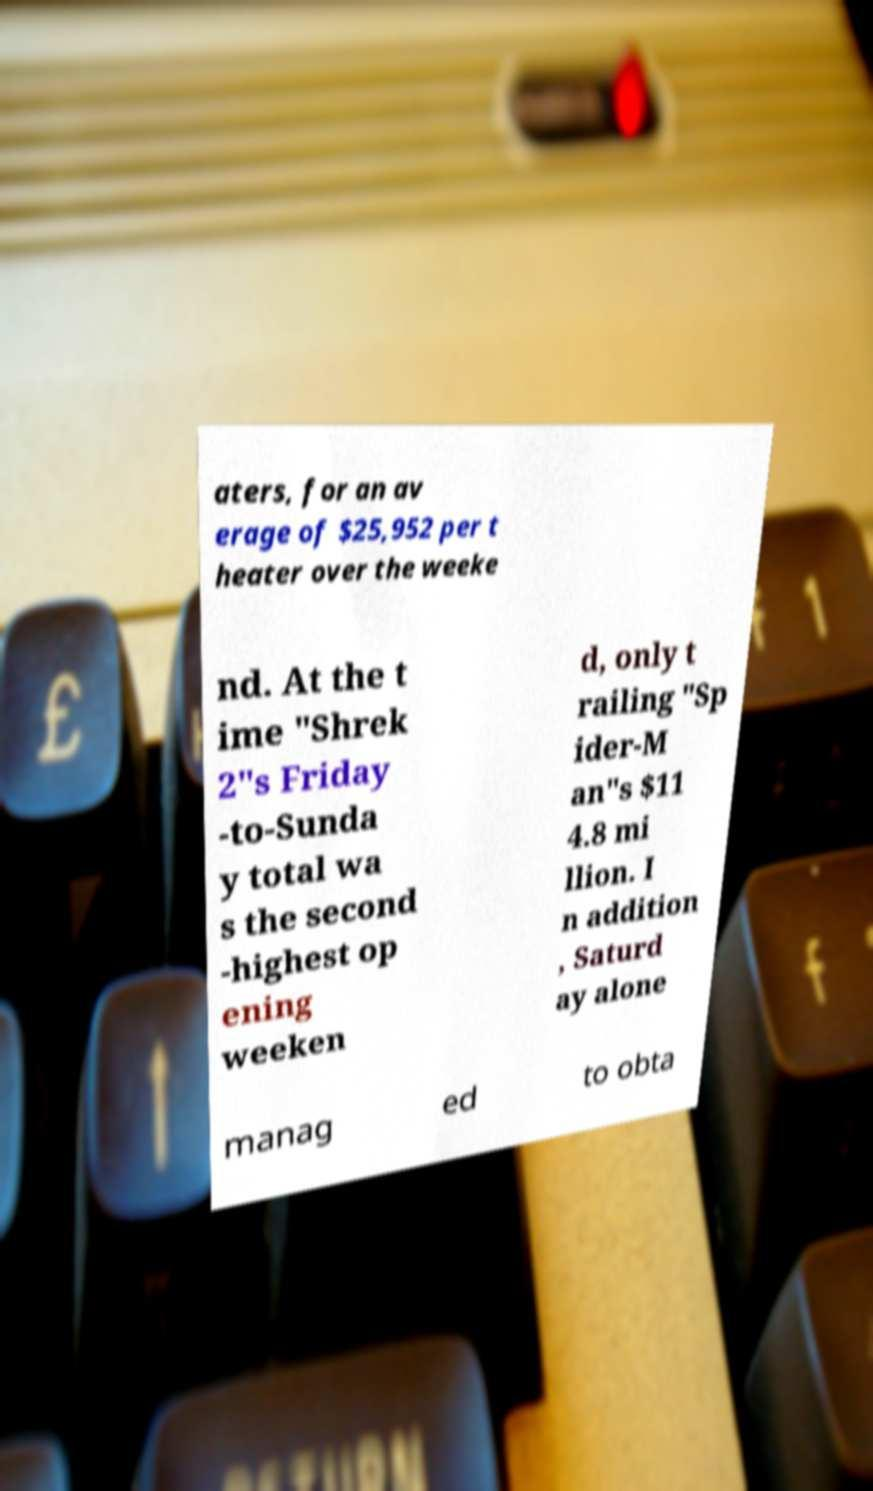Could you assist in decoding the text presented in this image and type it out clearly? aters, for an av erage of $25,952 per t heater over the weeke nd. At the t ime "Shrek 2"s Friday -to-Sunda y total wa s the second -highest op ening weeken d, only t railing "Sp ider-M an"s $11 4.8 mi llion. I n addition , Saturd ay alone manag ed to obta 